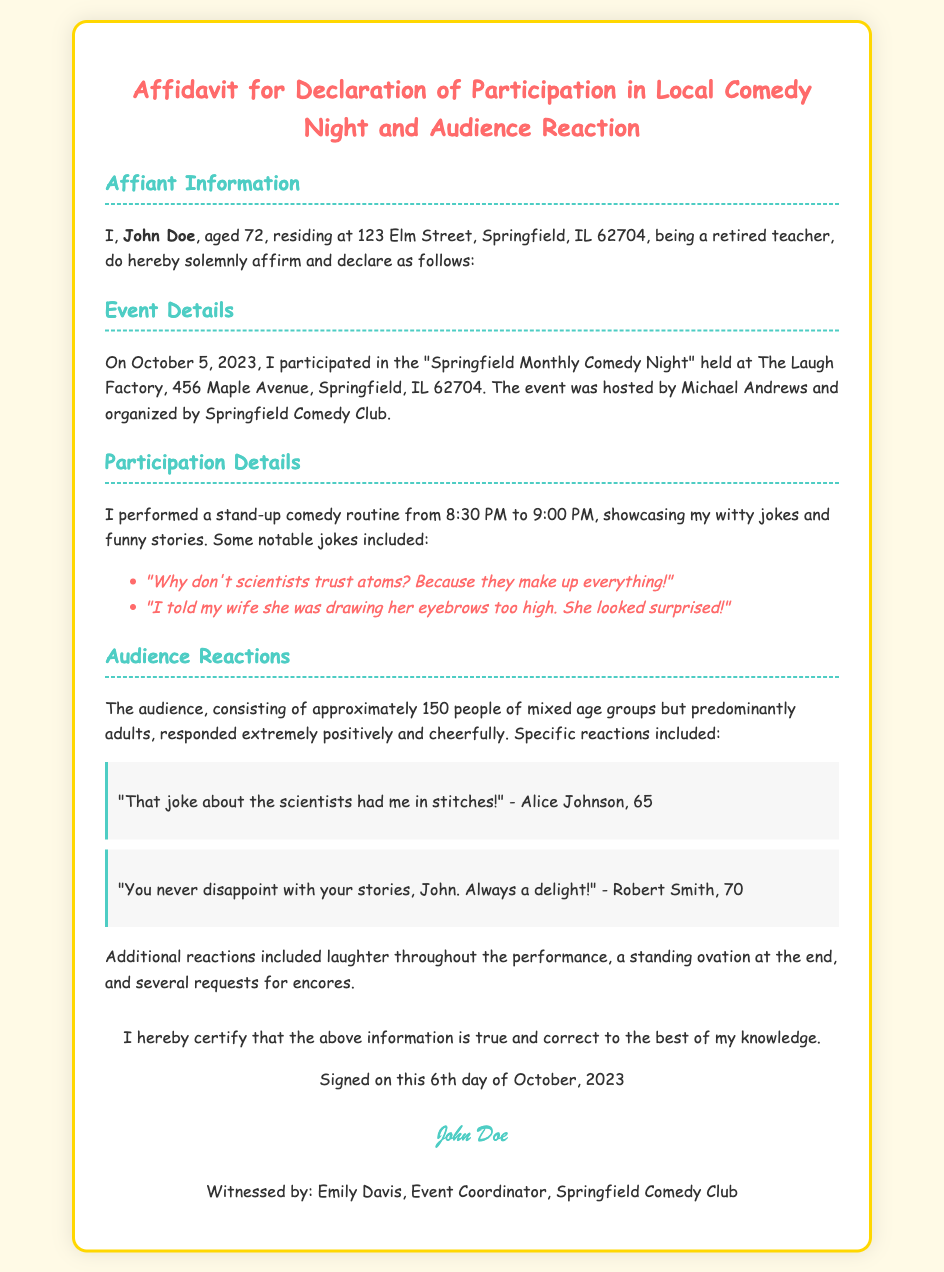What is the name of the affiant? The affiant is the person who signed the affidavit, identified in the document as John Doe.
Answer: John Doe What is the location of the event? The event took place at The Laugh Factory, which is specified in the event details.
Answer: The Laugh Factory When did the comedy night occur? The document states the specific date of the event in the Event Details section.
Answer: October 5, 2023 How many people were in the audience? The affidavit notes that the audience consisted of approximately 150 people.
Answer: 150 What type of performances did John Doe provide? The document describes the nature of the involvement of the affiant in the event.
Answer: Stand-up comedy routine What was one notable joke performed? The document lists specific jokes performed during the comedy night, providing examples.
Answer: "Why don't scientists trust atoms? Because they make up everything!" Who provided a witness signature? The document includes a section that specifies the witness to the affidavit.
Answer: Emily Davis What was the audience’s general reaction? The affidavit describes the audience's response during and after the performance, summarizing the overall sentiment.
Answer: Extremely positively and cheerfully What time did John Doe perform? The performance time is explicitly mentioned under Participation Details in the document.
Answer: 8:30 PM to 9:00 PM 